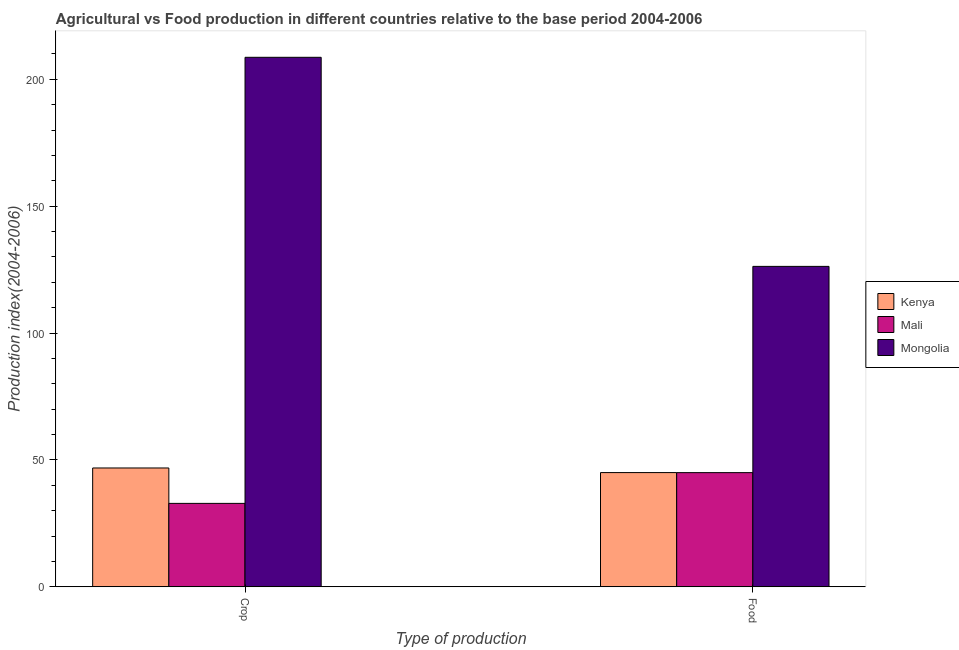Are the number of bars on each tick of the X-axis equal?
Offer a very short reply. Yes. What is the label of the 1st group of bars from the left?
Offer a very short reply. Crop. What is the crop production index in Mongolia?
Ensure brevity in your answer.  208.69. Across all countries, what is the maximum crop production index?
Your answer should be compact. 208.69. Across all countries, what is the minimum food production index?
Your answer should be very brief. 44.98. In which country was the food production index maximum?
Make the answer very short. Mongolia. In which country was the crop production index minimum?
Make the answer very short. Mali. What is the total crop production index in the graph?
Your response must be concise. 288.37. What is the difference between the crop production index in Mali and that in Mongolia?
Ensure brevity in your answer.  -175.83. What is the difference between the crop production index in Mongolia and the food production index in Kenya?
Provide a succinct answer. 163.69. What is the average crop production index per country?
Give a very brief answer. 96.12. What is the difference between the crop production index and food production index in Kenya?
Give a very brief answer. 1.82. In how many countries, is the food production index greater than 180 ?
Ensure brevity in your answer.  0. What is the ratio of the food production index in Mali to that in Mongolia?
Ensure brevity in your answer.  0.36. Is the crop production index in Mongolia less than that in Mali?
Your answer should be very brief. No. In how many countries, is the food production index greater than the average food production index taken over all countries?
Provide a succinct answer. 1. What does the 2nd bar from the left in Crop represents?
Provide a succinct answer. Mali. What does the 1st bar from the right in Crop represents?
Your answer should be very brief. Mongolia. How many bars are there?
Your answer should be compact. 6. Are all the bars in the graph horizontal?
Provide a succinct answer. No. How many countries are there in the graph?
Give a very brief answer. 3. What is the difference between two consecutive major ticks on the Y-axis?
Keep it short and to the point. 50. Where does the legend appear in the graph?
Provide a succinct answer. Center right. What is the title of the graph?
Your answer should be very brief. Agricultural vs Food production in different countries relative to the base period 2004-2006. What is the label or title of the X-axis?
Make the answer very short. Type of production. What is the label or title of the Y-axis?
Provide a short and direct response. Production index(2004-2006). What is the Production index(2004-2006) in Kenya in Crop?
Your answer should be very brief. 46.82. What is the Production index(2004-2006) in Mali in Crop?
Keep it short and to the point. 32.86. What is the Production index(2004-2006) of Mongolia in Crop?
Give a very brief answer. 208.69. What is the Production index(2004-2006) in Mali in Food?
Your response must be concise. 44.98. What is the Production index(2004-2006) of Mongolia in Food?
Your answer should be very brief. 126.28. Across all Type of production, what is the maximum Production index(2004-2006) in Kenya?
Provide a succinct answer. 46.82. Across all Type of production, what is the maximum Production index(2004-2006) of Mali?
Ensure brevity in your answer.  44.98. Across all Type of production, what is the maximum Production index(2004-2006) of Mongolia?
Provide a short and direct response. 208.69. Across all Type of production, what is the minimum Production index(2004-2006) in Kenya?
Make the answer very short. 45. Across all Type of production, what is the minimum Production index(2004-2006) in Mali?
Provide a succinct answer. 32.86. Across all Type of production, what is the minimum Production index(2004-2006) in Mongolia?
Make the answer very short. 126.28. What is the total Production index(2004-2006) of Kenya in the graph?
Provide a succinct answer. 91.82. What is the total Production index(2004-2006) in Mali in the graph?
Provide a succinct answer. 77.84. What is the total Production index(2004-2006) in Mongolia in the graph?
Your answer should be compact. 334.97. What is the difference between the Production index(2004-2006) in Kenya in Crop and that in Food?
Offer a terse response. 1.82. What is the difference between the Production index(2004-2006) of Mali in Crop and that in Food?
Your response must be concise. -12.12. What is the difference between the Production index(2004-2006) in Mongolia in Crop and that in Food?
Your answer should be very brief. 82.41. What is the difference between the Production index(2004-2006) of Kenya in Crop and the Production index(2004-2006) of Mali in Food?
Offer a terse response. 1.84. What is the difference between the Production index(2004-2006) in Kenya in Crop and the Production index(2004-2006) in Mongolia in Food?
Your answer should be compact. -79.46. What is the difference between the Production index(2004-2006) in Mali in Crop and the Production index(2004-2006) in Mongolia in Food?
Your response must be concise. -93.42. What is the average Production index(2004-2006) of Kenya per Type of production?
Your answer should be very brief. 45.91. What is the average Production index(2004-2006) of Mali per Type of production?
Provide a succinct answer. 38.92. What is the average Production index(2004-2006) in Mongolia per Type of production?
Ensure brevity in your answer.  167.49. What is the difference between the Production index(2004-2006) in Kenya and Production index(2004-2006) in Mali in Crop?
Ensure brevity in your answer.  13.96. What is the difference between the Production index(2004-2006) in Kenya and Production index(2004-2006) in Mongolia in Crop?
Ensure brevity in your answer.  -161.87. What is the difference between the Production index(2004-2006) of Mali and Production index(2004-2006) of Mongolia in Crop?
Give a very brief answer. -175.83. What is the difference between the Production index(2004-2006) in Kenya and Production index(2004-2006) in Mongolia in Food?
Your response must be concise. -81.28. What is the difference between the Production index(2004-2006) in Mali and Production index(2004-2006) in Mongolia in Food?
Your answer should be compact. -81.3. What is the ratio of the Production index(2004-2006) in Kenya in Crop to that in Food?
Your answer should be very brief. 1.04. What is the ratio of the Production index(2004-2006) in Mali in Crop to that in Food?
Your response must be concise. 0.73. What is the ratio of the Production index(2004-2006) of Mongolia in Crop to that in Food?
Ensure brevity in your answer.  1.65. What is the difference between the highest and the second highest Production index(2004-2006) of Kenya?
Your response must be concise. 1.82. What is the difference between the highest and the second highest Production index(2004-2006) of Mali?
Your answer should be very brief. 12.12. What is the difference between the highest and the second highest Production index(2004-2006) in Mongolia?
Ensure brevity in your answer.  82.41. What is the difference between the highest and the lowest Production index(2004-2006) of Kenya?
Give a very brief answer. 1.82. What is the difference between the highest and the lowest Production index(2004-2006) of Mali?
Make the answer very short. 12.12. What is the difference between the highest and the lowest Production index(2004-2006) in Mongolia?
Give a very brief answer. 82.41. 